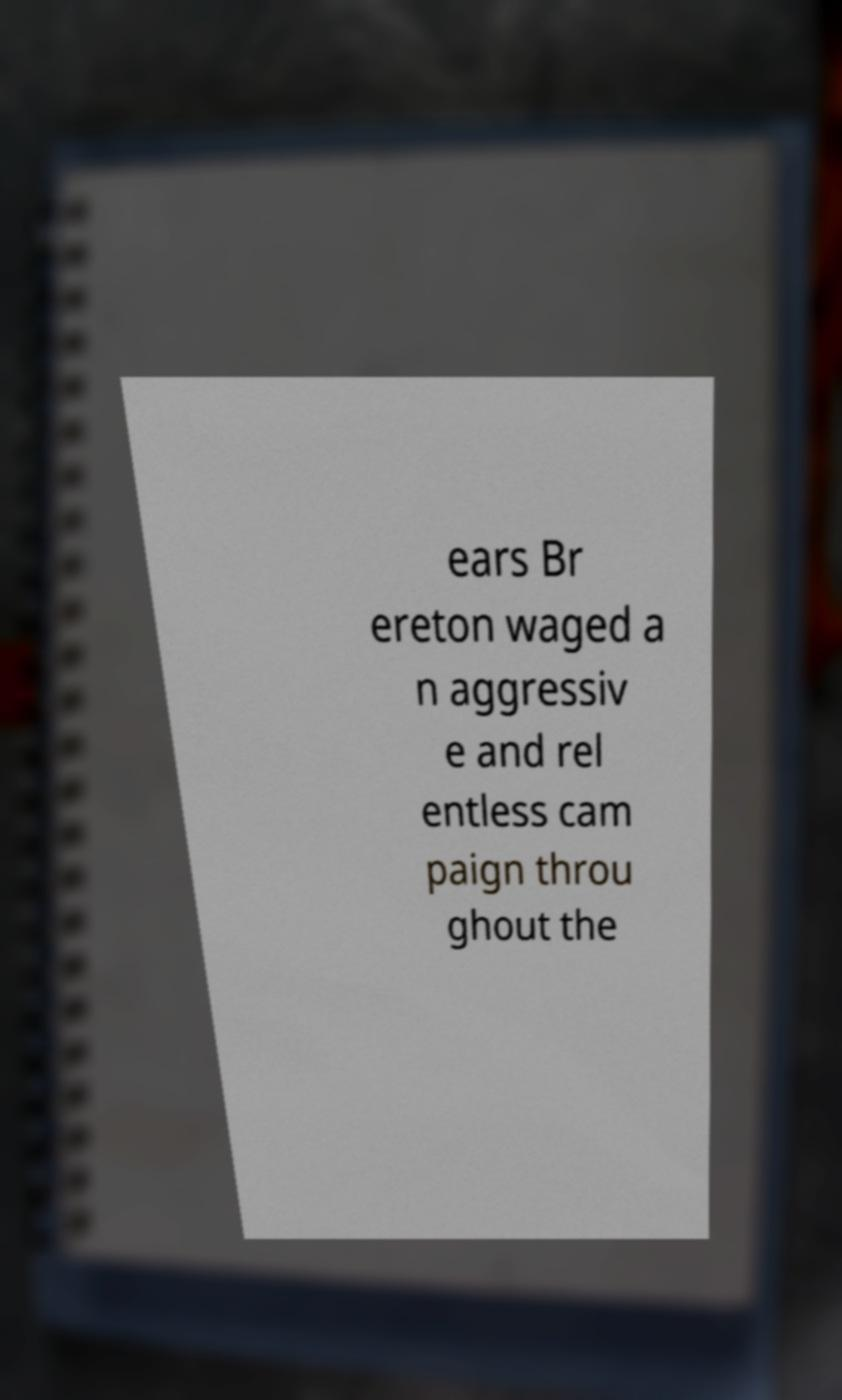Could you assist in decoding the text presented in this image and type it out clearly? ears Br ereton waged a n aggressiv e and rel entless cam paign throu ghout the 